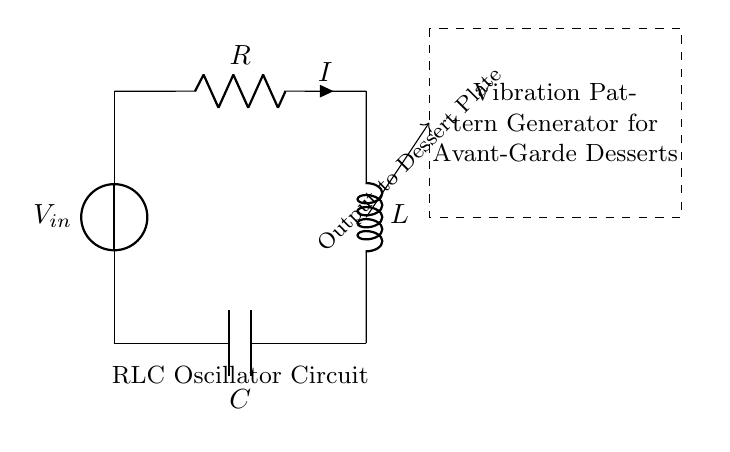What is the voltage source labeled in the circuit? The voltage source in the circuit is labeled as V_{in}, which indicates the input voltage supplied to the circuit.
Answer: V_{in} What components are found in the RLC circuit? The components in the RLC circuit are a resistor (R), an inductor (L), and a capacitor (C), which are essential for creating oscillations in the circuit.
Answer: R, L, C What does the dashed rectangle represent in the circuit? The dashed rectangle in the circuit represents a vibration pattern generator specifically designed for avant-garde dessert presentations, indicating where the output is processed.
Answer: Vibration Pattern Generator for Avant-Garde Desserts Which direction does the current flow from the voltage source? The current flows from the voltage source (V_{in}) through the resistor (R), indicating that the circuit is designed to facilitate current flow in a specific direction from the input source.
Answer: From top to bottom How is the output delivered to the dessert plate? The output is delivered to the dessert plate through the connection indicated with an arrow stemming from the inductor (L), which suggests that it transmits the generated vibration patterns.
Answer: Output to Dessert Plate What is the configuration of the RLC components in this circuit? The RLC components are connected in series; the resistor is followed by the inductor and then the capacitor, forming a series connection that allows the components to work together in oscillation.
Answer: Series Connection 